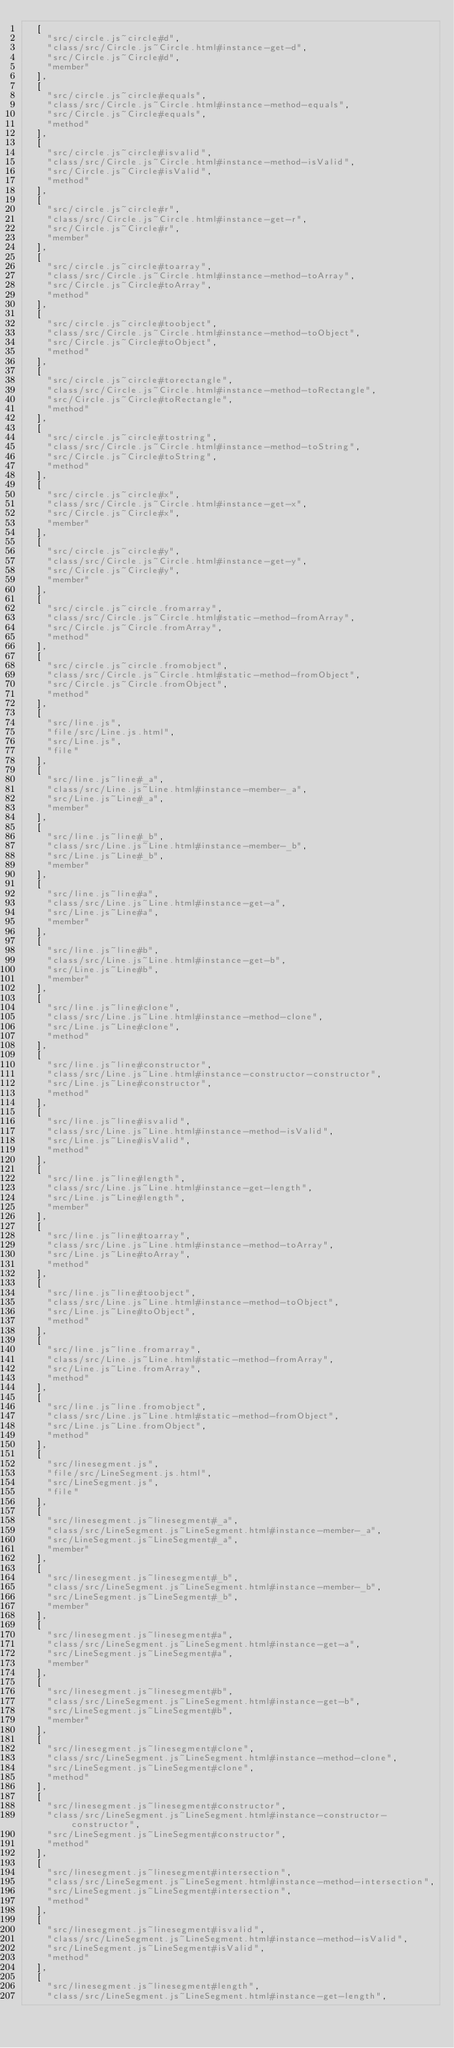Convert code to text. <code><loc_0><loc_0><loc_500><loc_500><_JavaScript_>  [
    "src/circle.js~circle#d",
    "class/src/Circle.js~Circle.html#instance-get-d",
    "src/Circle.js~Circle#d",
    "member"
  ],
  [
    "src/circle.js~circle#equals",
    "class/src/Circle.js~Circle.html#instance-method-equals",
    "src/Circle.js~Circle#equals",
    "method"
  ],
  [
    "src/circle.js~circle#isvalid",
    "class/src/Circle.js~Circle.html#instance-method-isValid",
    "src/Circle.js~Circle#isValid",
    "method"
  ],
  [
    "src/circle.js~circle#r",
    "class/src/Circle.js~Circle.html#instance-get-r",
    "src/Circle.js~Circle#r",
    "member"
  ],
  [
    "src/circle.js~circle#toarray",
    "class/src/Circle.js~Circle.html#instance-method-toArray",
    "src/Circle.js~Circle#toArray",
    "method"
  ],
  [
    "src/circle.js~circle#toobject",
    "class/src/Circle.js~Circle.html#instance-method-toObject",
    "src/Circle.js~Circle#toObject",
    "method"
  ],
  [
    "src/circle.js~circle#torectangle",
    "class/src/Circle.js~Circle.html#instance-method-toRectangle",
    "src/Circle.js~Circle#toRectangle",
    "method"
  ],
  [
    "src/circle.js~circle#tostring",
    "class/src/Circle.js~Circle.html#instance-method-toString",
    "src/Circle.js~Circle#toString",
    "method"
  ],
  [
    "src/circle.js~circle#x",
    "class/src/Circle.js~Circle.html#instance-get-x",
    "src/Circle.js~Circle#x",
    "member"
  ],
  [
    "src/circle.js~circle#y",
    "class/src/Circle.js~Circle.html#instance-get-y",
    "src/Circle.js~Circle#y",
    "member"
  ],
  [
    "src/circle.js~circle.fromarray",
    "class/src/Circle.js~Circle.html#static-method-fromArray",
    "src/Circle.js~Circle.fromArray",
    "method"
  ],
  [
    "src/circle.js~circle.fromobject",
    "class/src/Circle.js~Circle.html#static-method-fromObject",
    "src/Circle.js~Circle.fromObject",
    "method"
  ],
  [
    "src/line.js",
    "file/src/Line.js.html",
    "src/Line.js",
    "file"
  ],
  [
    "src/line.js~line#_a",
    "class/src/Line.js~Line.html#instance-member-_a",
    "src/Line.js~Line#_a",
    "member"
  ],
  [
    "src/line.js~line#_b",
    "class/src/Line.js~Line.html#instance-member-_b",
    "src/Line.js~Line#_b",
    "member"
  ],
  [
    "src/line.js~line#a",
    "class/src/Line.js~Line.html#instance-get-a",
    "src/Line.js~Line#a",
    "member"
  ],
  [
    "src/line.js~line#b",
    "class/src/Line.js~Line.html#instance-get-b",
    "src/Line.js~Line#b",
    "member"
  ],
  [
    "src/line.js~line#clone",
    "class/src/Line.js~Line.html#instance-method-clone",
    "src/Line.js~Line#clone",
    "method"
  ],
  [
    "src/line.js~line#constructor",
    "class/src/Line.js~Line.html#instance-constructor-constructor",
    "src/Line.js~Line#constructor",
    "method"
  ],
  [
    "src/line.js~line#isvalid",
    "class/src/Line.js~Line.html#instance-method-isValid",
    "src/Line.js~Line#isValid",
    "method"
  ],
  [
    "src/line.js~line#length",
    "class/src/Line.js~Line.html#instance-get-length",
    "src/Line.js~Line#length",
    "member"
  ],
  [
    "src/line.js~line#toarray",
    "class/src/Line.js~Line.html#instance-method-toArray",
    "src/Line.js~Line#toArray",
    "method"
  ],
  [
    "src/line.js~line#toobject",
    "class/src/Line.js~Line.html#instance-method-toObject",
    "src/Line.js~Line#toObject",
    "method"
  ],
  [
    "src/line.js~line.fromarray",
    "class/src/Line.js~Line.html#static-method-fromArray",
    "src/Line.js~Line.fromArray",
    "method"
  ],
  [
    "src/line.js~line.fromobject",
    "class/src/Line.js~Line.html#static-method-fromObject",
    "src/Line.js~Line.fromObject",
    "method"
  ],
  [
    "src/linesegment.js",
    "file/src/LineSegment.js.html",
    "src/LineSegment.js",
    "file"
  ],
  [
    "src/linesegment.js~linesegment#_a",
    "class/src/LineSegment.js~LineSegment.html#instance-member-_a",
    "src/LineSegment.js~LineSegment#_a",
    "member"
  ],
  [
    "src/linesegment.js~linesegment#_b",
    "class/src/LineSegment.js~LineSegment.html#instance-member-_b",
    "src/LineSegment.js~LineSegment#_b",
    "member"
  ],
  [
    "src/linesegment.js~linesegment#a",
    "class/src/LineSegment.js~LineSegment.html#instance-get-a",
    "src/LineSegment.js~LineSegment#a",
    "member"
  ],
  [
    "src/linesegment.js~linesegment#b",
    "class/src/LineSegment.js~LineSegment.html#instance-get-b",
    "src/LineSegment.js~LineSegment#b",
    "member"
  ],
  [
    "src/linesegment.js~linesegment#clone",
    "class/src/LineSegment.js~LineSegment.html#instance-method-clone",
    "src/LineSegment.js~LineSegment#clone",
    "method"
  ],
  [
    "src/linesegment.js~linesegment#constructor",
    "class/src/LineSegment.js~LineSegment.html#instance-constructor-constructor",
    "src/LineSegment.js~LineSegment#constructor",
    "method"
  ],
  [
    "src/linesegment.js~linesegment#intersection",
    "class/src/LineSegment.js~LineSegment.html#instance-method-intersection",
    "src/LineSegment.js~LineSegment#intersection",
    "method"
  ],
  [
    "src/linesegment.js~linesegment#isvalid",
    "class/src/LineSegment.js~LineSegment.html#instance-method-isValid",
    "src/LineSegment.js~LineSegment#isValid",
    "method"
  ],
  [
    "src/linesegment.js~linesegment#length",
    "class/src/LineSegment.js~LineSegment.html#instance-get-length",</code> 